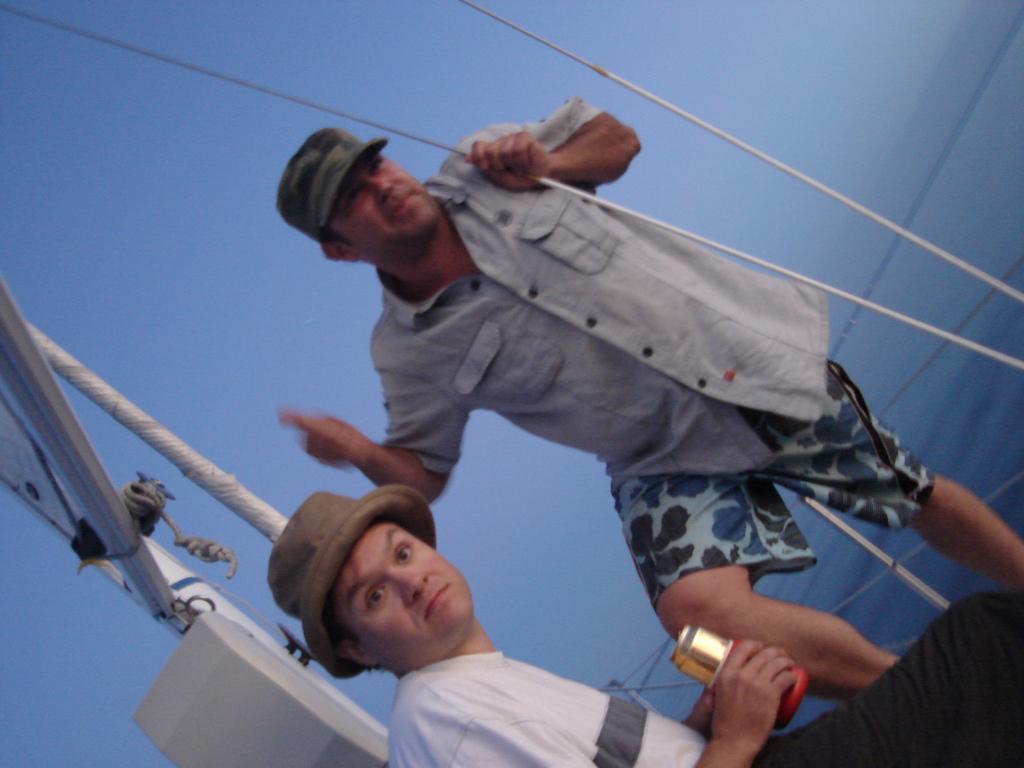Describe this image in one or two sentences. In this picture there is a person wearing white T-shirt is sitting and there are few objects behind him and there is another person standing beside him and there is water in the background. 